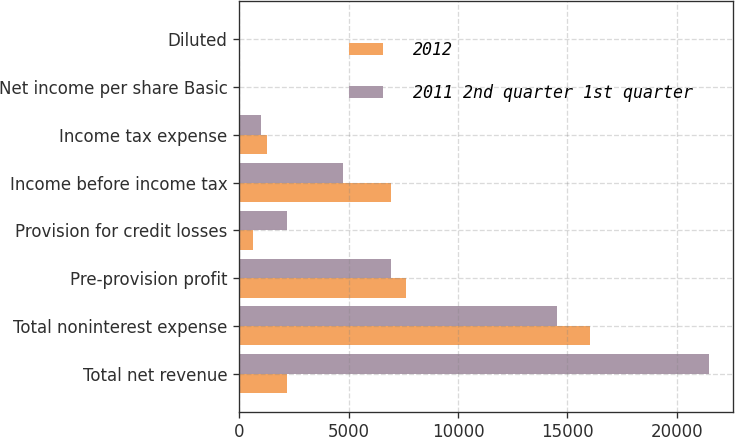<chart> <loc_0><loc_0><loc_500><loc_500><stacked_bar_chart><ecel><fcel>Total net revenue<fcel>Total noninterest expense<fcel>Pre-provision profit<fcel>Provision for credit losses<fcel>Income before income tax<fcel>Income tax expense<fcel>Net income per share Basic<fcel>Diluted<nl><fcel>2012<fcel>2184<fcel>16047<fcel>7606<fcel>656<fcel>6950<fcel>1258<fcel>1.4<fcel>1.39<nl><fcel>2011 2nd quarter 1st quarter<fcel>21471<fcel>14540<fcel>6931<fcel>2184<fcel>4747<fcel>1019<fcel>0.9<fcel>0.9<nl></chart> 